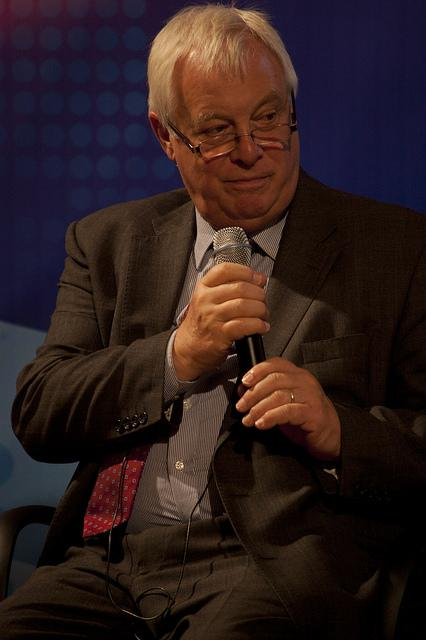What is he about to do?

Choices:
A) speak
B) punish people
C) find food
D) eat dinner speak 